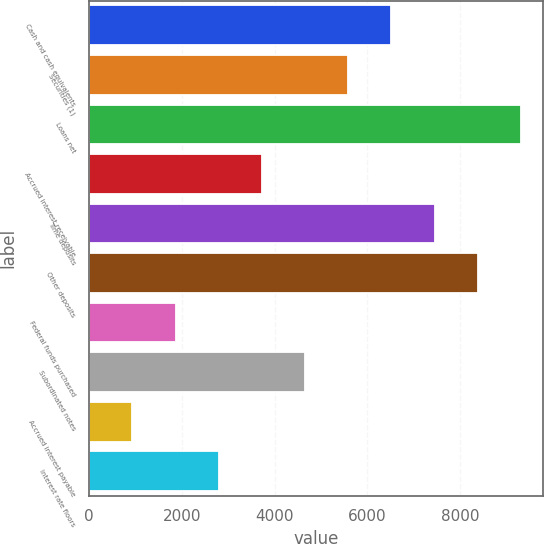Convert chart. <chart><loc_0><loc_0><loc_500><loc_500><bar_chart><fcel>Cash and cash equivalents<fcel>Securities (1)<fcel>Loans net<fcel>Accrued interest receivable<fcel>Time deposits<fcel>Other deposits<fcel>Federal funds purchased<fcel>Subordinated notes<fcel>Accrued interest payable<fcel>Interest rate floors<nl><fcel>6522.66<fcel>5590.88<fcel>9318<fcel>3727.32<fcel>7454.44<fcel>8386.22<fcel>1863.76<fcel>4659.1<fcel>931.98<fcel>2795.54<nl></chart> 